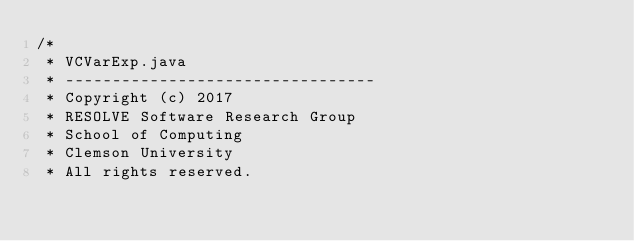Convert code to text. <code><loc_0><loc_0><loc_500><loc_500><_Java_>/*
 * VCVarExp.java
 * ---------------------------------
 * Copyright (c) 2017
 * RESOLVE Software Research Group
 * School of Computing
 * Clemson University
 * All rights reserved.</code> 